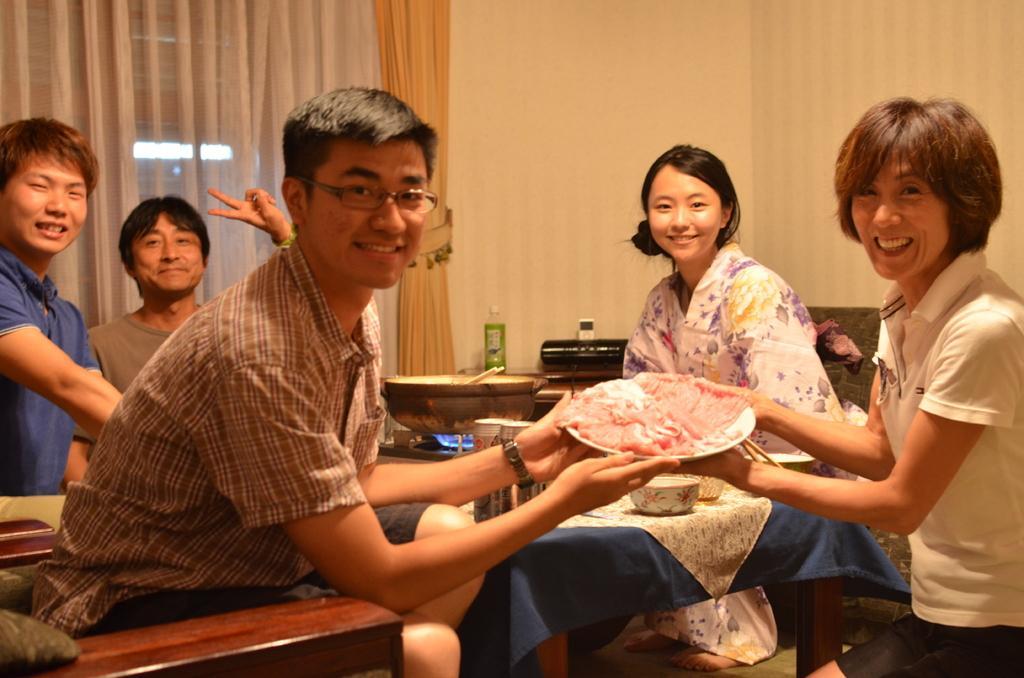Could you give a brief overview of what you see in this image? In this image there are some people sitting on chairs, and in the foreground there are two people who are holding a plate. And in the plate there is meat and there is one table in the center, on the table there are some bowls, stove. On the stove there is one pan and there are some utensils, and in the background there is wall, curtains, window, lights and some objects. At the bottom there is floor. 